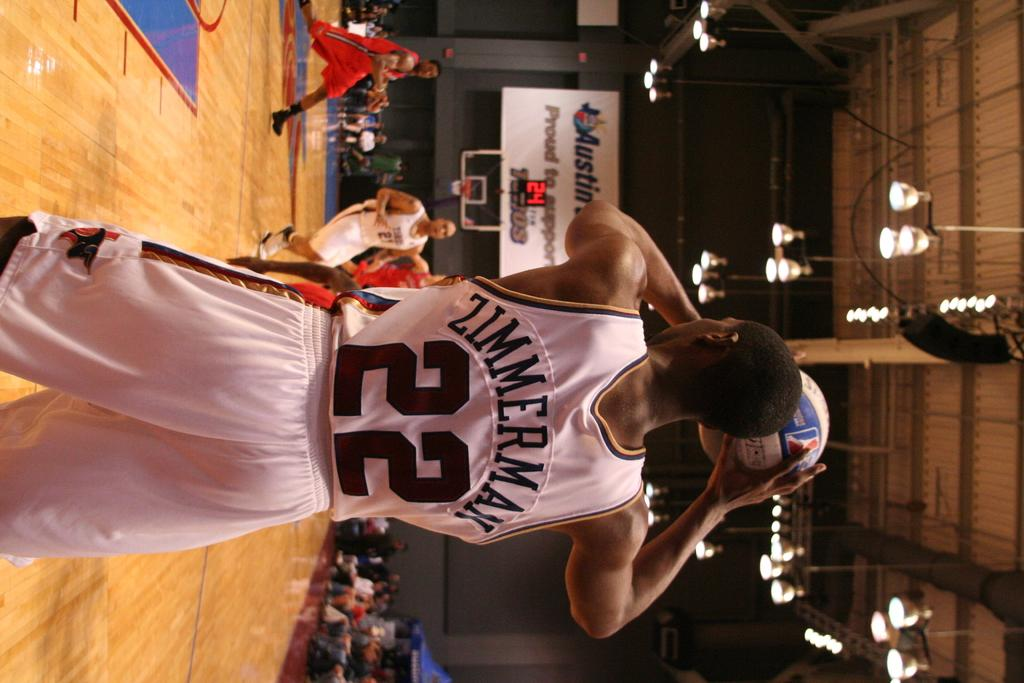<image>
Relay a brief, clear account of the picture shown. A basketball player named Zimmerman on the court ready to shoot the ball. 